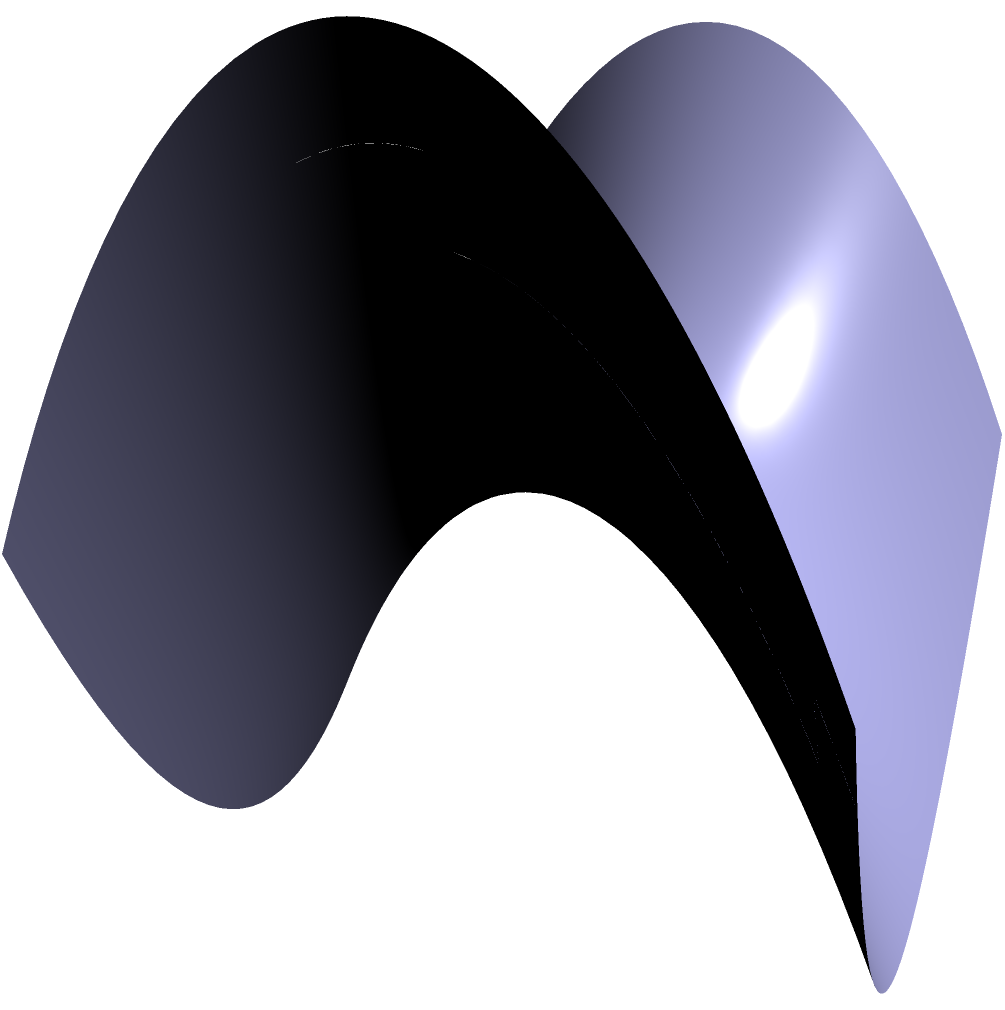On a saddle-shaped surface described by the equation $z = x^2 - y^2$, a geodesic is drawn as shown in red. How does this geodesic differ from a straight line in Euclidean space, and what implications does this have for our understanding of the shortest path between two points on curved surfaces? To understand the difference between geodesics on a saddle-shaped surface and straight lines in Euclidean space, we need to consider the following steps:

1. Definition of a geodesic: A geodesic is the shortest path between two points on a curved surface. In Euclidean space, this is always a straight line.

2. Properties of the saddle surface:
   - The surface is described by $z = x^2 - y^2$
   - It has negative curvature (curves upward in one direction and downward in the perpendicular direction)

3. Behavior of the geodesic:
   - The red curve in the diagram represents a geodesic on this surface
   - It appears curved when viewed from our 3D perspective

4. Differences from Euclidean straight lines:
   - The geodesic follows the curvature of the surface
   - It is not a straight line when projected onto the xy-plane
   - The path minimizes the distance traveled on the surface, not in 3D space

5. Implications for shortest paths:
   - On curved surfaces, the shortest path between two points is not always a straight line
   - The curvature of the surface influences the path of the geodesic
   - This challenges our Euclidean intuition about shortest distances

6. Real-world applications:
   - In general relativity, geodesics describe the paths of objects in curved spacetime
   - In cartography, understanding geodesics is crucial for accurate map projections

7. Mathematical formulation:
   - Geodesics satisfy the geodesic equation, which involves the Christoffel symbols of the surface
   - $$\frac{d^2x^\mu}{d\tau^2} + \Gamma^\mu_{\alpha\beta}\frac{dx^\alpha}{d\tau}\frac{dx^\beta}{d\tau} = 0$$
   where $\Gamma^\mu_{\alpha\beta}$ are the Christoffel symbols and $\tau$ is a parameter along the curve

This analysis demonstrates that geodesics on curved surfaces fundamentally differ from straight lines in Euclidean space, challenging our intuitive understanding of shortest paths and distances.
Answer: Geodesics on curved surfaces follow the surface's curvature, unlike Euclidean straight lines, revealing that the shortest path between two points on a curved surface is not always a straight line. 